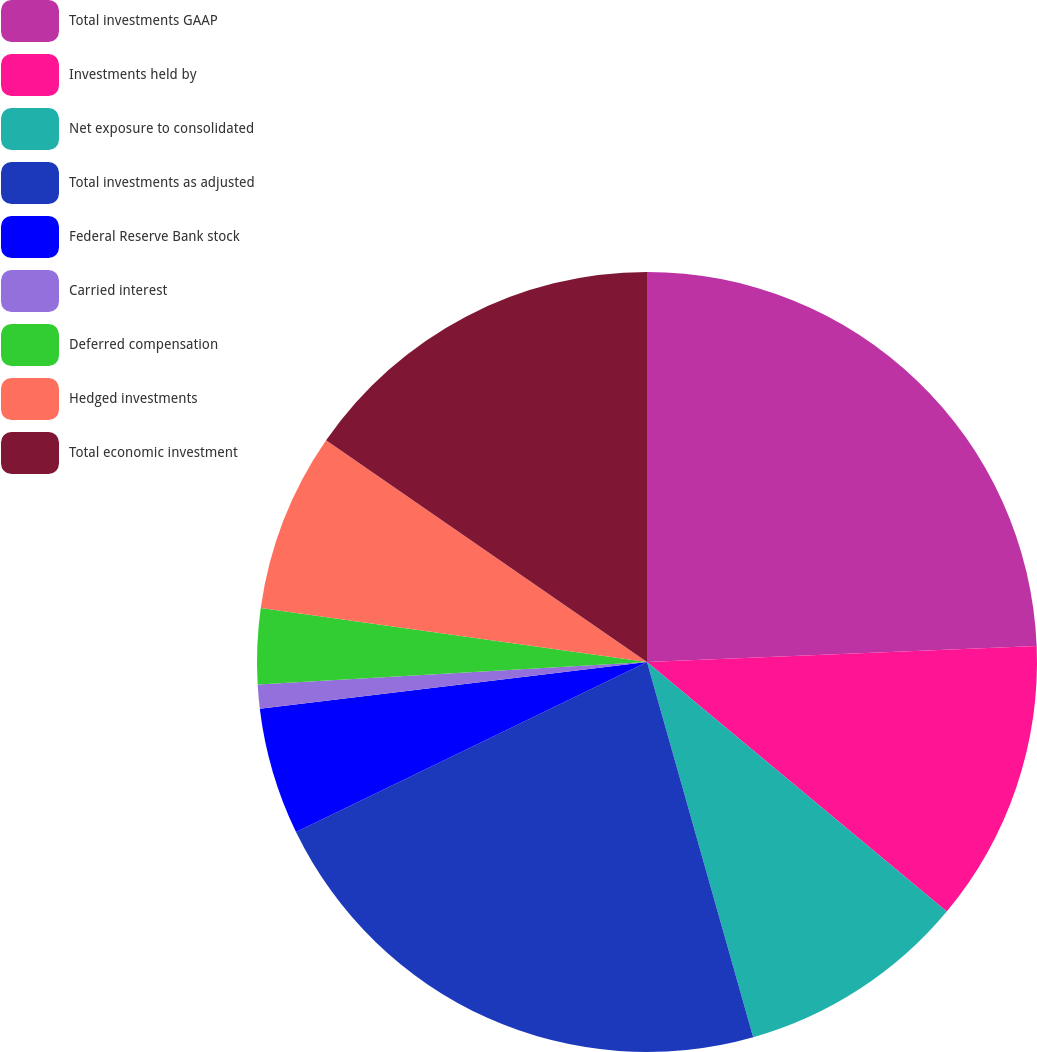Convert chart. <chart><loc_0><loc_0><loc_500><loc_500><pie_chart><fcel>Total investments GAAP<fcel>Investments held by<fcel>Net exposure to consolidated<fcel>Total investments as adjusted<fcel>Federal Reserve Bank stock<fcel>Carried interest<fcel>Deferred compensation<fcel>Hedged investments<fcel>Total economic investment<nl><fcel>24.35%<fcel>11.7%<fcel>9.56%<fcel>22.21%<fcel>5.27%<fcel>0.99%<fcel>3.13%<fcel>7.41%<fcel>15.38%<nl></chart> 